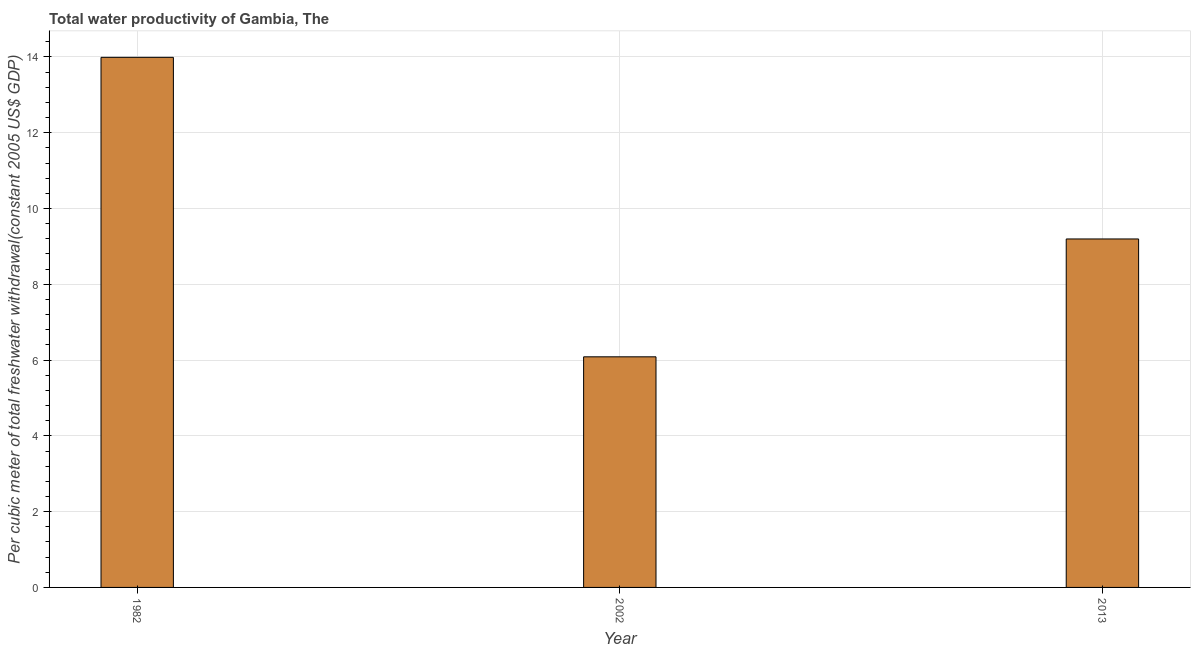Does the graph contain any zero values?
Offer a very short reply. No. Does the graph contain grids?
Offer a very short reply. Yes. What is the title of the graph?
Your answer should be very brief. Total water productivity of Gambia, The. What is the label or title of the X-axis?
Give a very brief answer. Year. What is the label or title of the Y-axis?
Give a very brief answer. Per cubic meter of total freshwater withdrawal(constant 2005 US$ GDP). What is the total water productivity in 1982?
Offer a very short reply. 13.99. Across all years, what is the maximum total water productivity?
Give a very brief answer. 13.99. Across all years, what is the minimum total water productivity?
Your response must be concise. 6.09. In which year was the total water productivity maximum?
Your answer should be very brief. 1982. What is the sum of the total water productivity?
Offer a very short reply. 29.27. What is the difference between the total water productivity in 1982 and 2013?
Your answer should be compact. 4.79. What is the average total water productivity per year?
Your answer should be very brief. 9.76. What is the median total water productivity?
Provide a short and direct response. 9.2. Do a majority of the years between 1982 and 2013 (inclusive) have total water productivity greater than 2.4 US$?
Offer a terse response. Yes. What is the ratio of the total water productivity in 1982 to that in 2002?
Give a very brief answer. 2.3. Is the difference between the total water productivity in 2002 and 2013 greater than the difference between any two years?
Give a very brief answer. No. What is the difference between the highest and the second highest total water productivity?
Provide a succinct answer. 4.79. Is the sum of the total water productivity in 1982 and 2013 greater than the maximum total water productivity across all years?
Your answer should be compact. Yes. How many bars are there?
Your answer should be compact. 3. How many years are there in the graph?
Offer a terse response. 3. What is the Per cubic meter of total freshwater withdrawal(constant 2005 US$ GDP) in 1982?
Offer a very short reply. 13.99. What is the Per cubic meter of total freshwater withdrawal(constant 2005 US$ GDP) in 2002?
Your response must be concise. 6.09. What is the Per cubic meter of total freshwater withdrawal(constant 2005 US$ GDP) in 2013?
Offer a terse response. 9.2. What is the difference between the Per cubic meter of total freshwater withdrawal(constant 2005 US$ GDP) in 1982 and 2002?
Provide a short and direct response. 7.9. What is the difference between the Per cubic meter of total freshwater withdrawal(constant 2005 US$ GDP) in 1982 and 2013?
Provide a succinct answer. 4.79. What is the difference between the Per cubic meter of total freshwater withdrawal(constant 2005 US$ GDP) in 2002 and 2013?
Provide a succinct answer. -3.11. What is the ratio of the Per cubic meter of total freshwater withdrawal(constant 2005 US$ GDP) in 1982 to that in 2002?
Your answer should be compact. 2.3. What is the ratio of the Per cubic meter of total freshwater withdrawal(constant 2005 US$ GDP) in 1982 to that in 2013?
Your answer should be very brief. 1.52. What is the ratio of the Per cubic meter of total freshwater withdrawal(constant 2005 US$ GDP) in 2002 to that in 2013?
Ensure brevity in your answer.  0.66. 